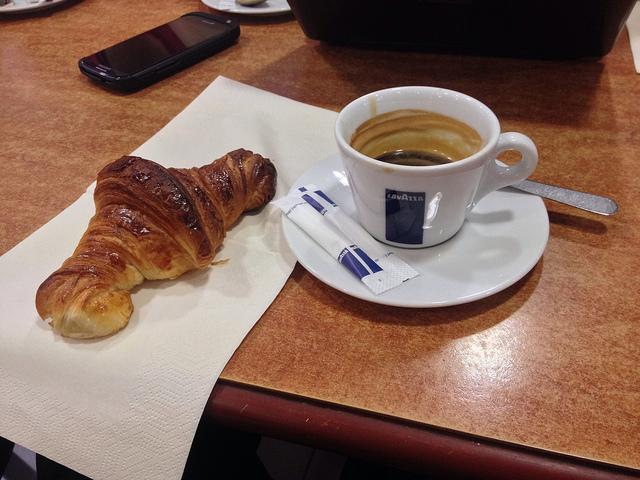What color is the block in the middle of the cup on the right? Please explain your reasoning. blue. Logos are usually distinctive and two or more colors. blue and white colors are coordinated with table items. 